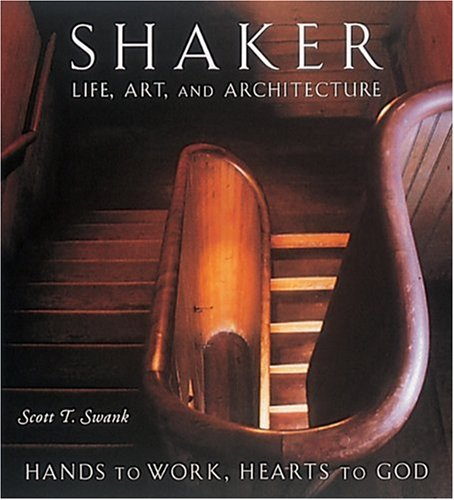What might be expected to learn from a book with such a title focussing on the Shakers? From a book with this title, one can expect to learn about the Shakers' dedication to their work and God, showcased through their art, crafts, and uniquely minimalist architectural styles, illustrating their spiritual and communal life principles. 